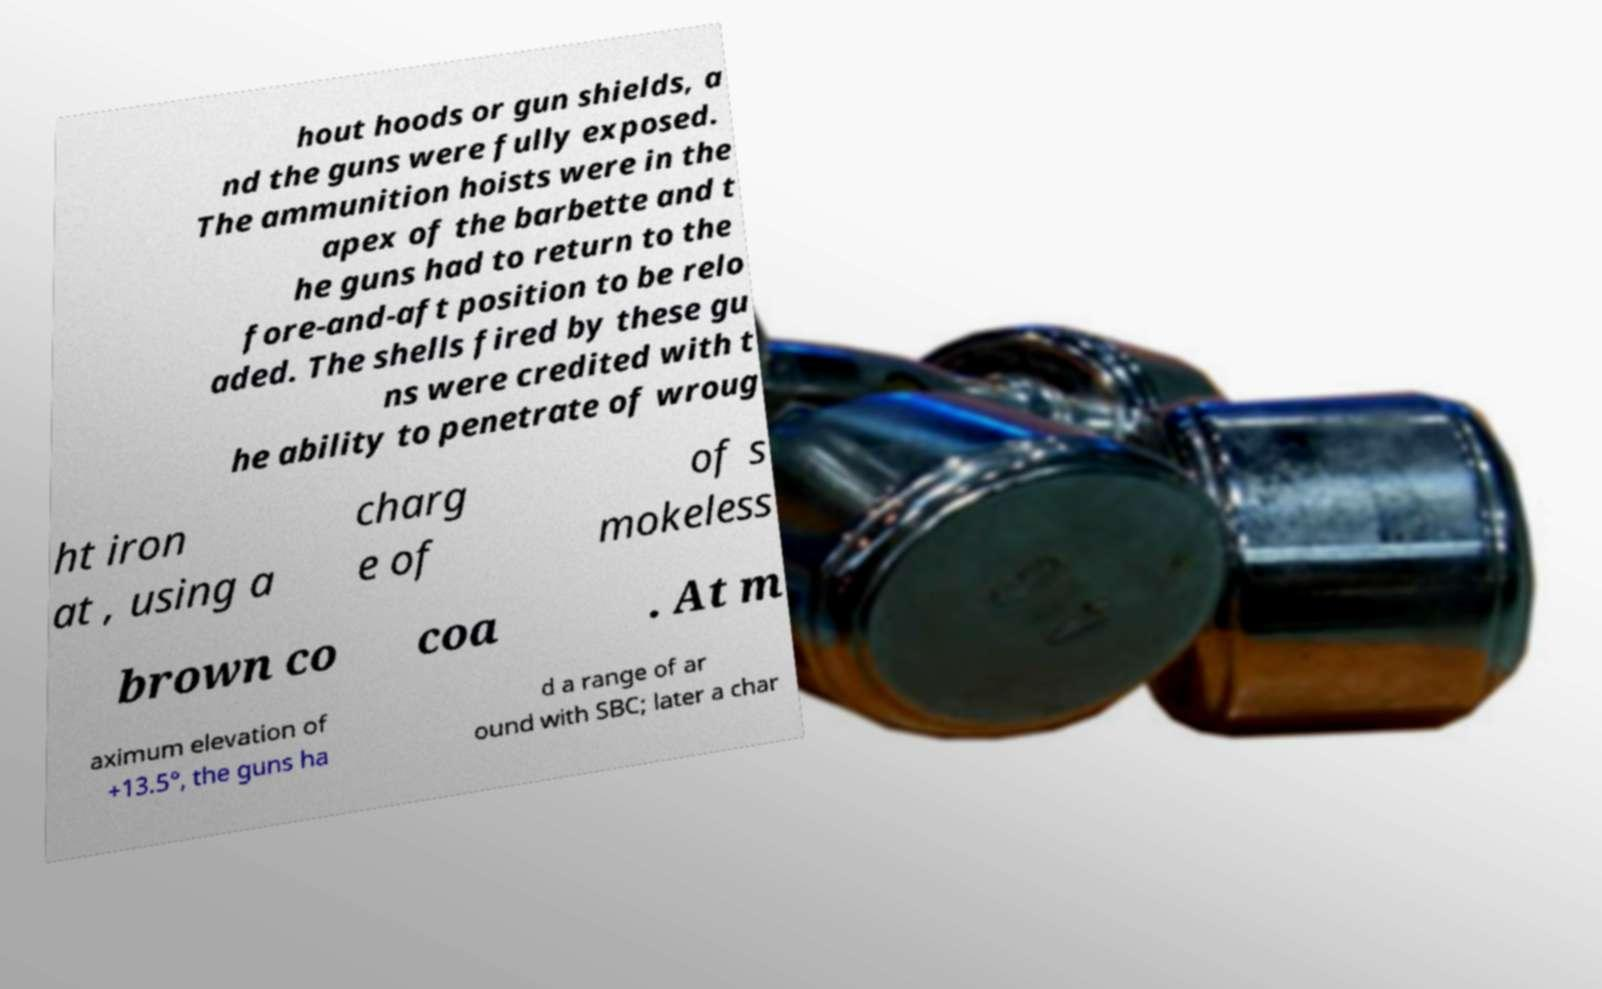I need the written content from this picture converted into text. Can you do that? hout hoods or gun shields, a nd the guns were fully exposed. The ammunition hoists were in the apex of the barbette and t he guns had to return to the fore-and-aft position to be relo aded. The shells fired by these gu ns were credited with t he ability to penetrate of wroug ht iron at , using a charg e of of s mokeless brown co coa . At m aximum elevation of +13.5°, the guns ha d a range of ar ound with SBC; later a char 